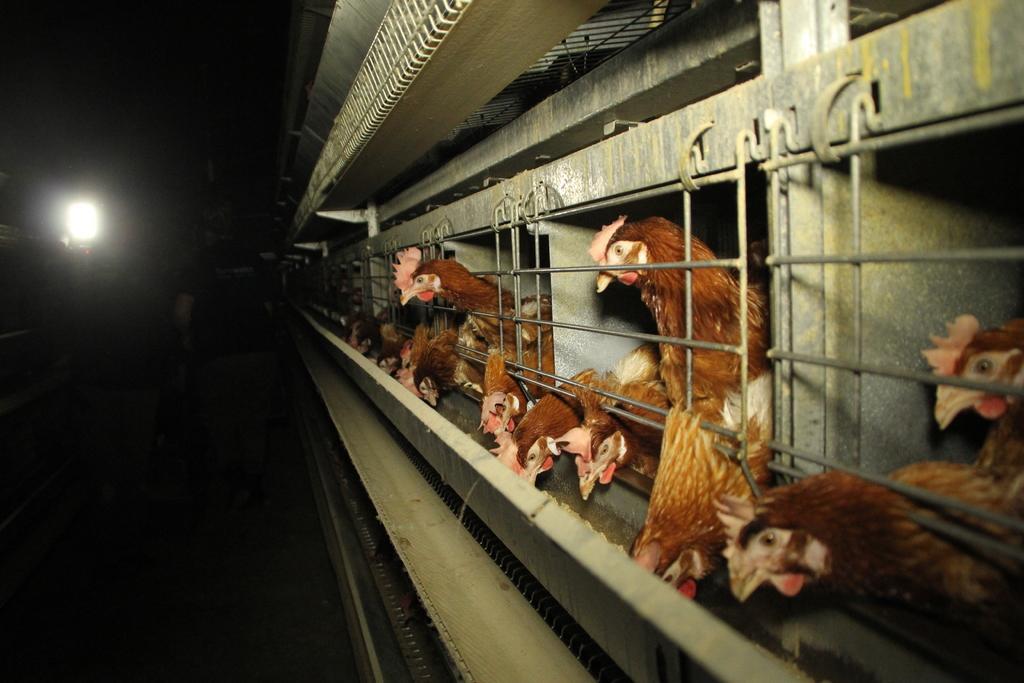Please provide a concise description of this image. This picture is taken inside a poultry. Few hens are behind the fence. Few hens are eating food. There is a person standing on the floor. Left side there is a light. 